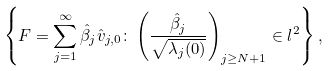<formula> <loc_0><loc_0><loc_500><loc_500>\left \{ F = \sum _ { j = 1 } ^ { \infty } \hat { \beta } _ { j } \hat { v } _ { j , 0 } \colon \left ( \frac { \hat { \beta } _ { j } } { \sqrt { \lambda _ { j } ( 0 ) } } \right ) _ { j \geq N + 1 } \in l ^ { 2 } \right \} ,</formula> 